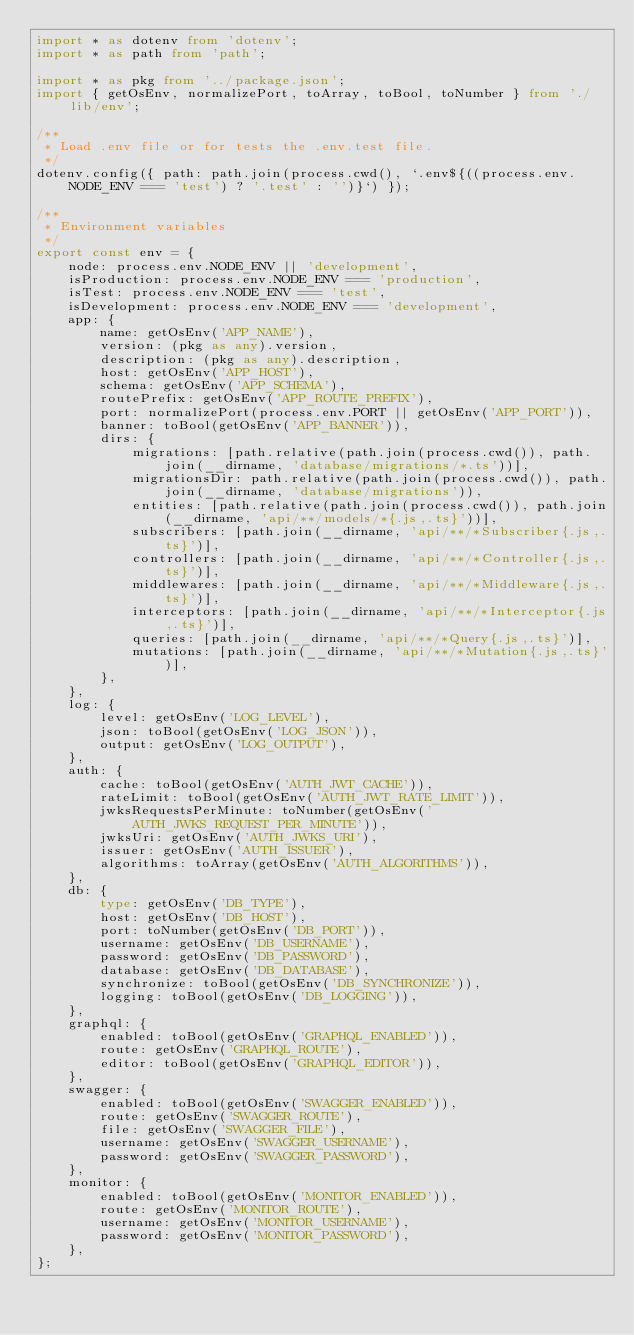Convert code to text. <code><loc_0><loc_0><loc_500><loc_500><_TypeScript_>import * as dotenv from 'dotenv';
import * as path from 'path';

import * as pkg from '../package.json';
import { getOsEnv, normalizePort, toArray, toBool, toNumber } from './lib/env';

/**
 * Load .env file or for tests the .env.test file.
 */
dotenv.config({ path: path.join(process.cwd(), `.env${((process.env.NODE_ENV === 'test') ? '.test' : '')}`) });

/**
 * Environment variables
 */
export const env = {
    node: process.env.NODE_ENV || 'development',
    isProduction: process.env.NODE_ENV === 'production',
    isTest: process.env.NODE_ENV === 'test',
    isDevelopment: process.env.NODE_ENV === 'development',
    app: {
        name: getOsEnv('APP_NAME'),
        version: (pkg as any).version,
        description: (pkg as any).description,
        host: getOsEnv('APP_HOST'),
        schema: getOsEnv('APP_SCHEMA'),
        routePrefix: getOsEnv('APP_ROUTE_PREFIX'),
        port: normalizePort(process.env.PORT || getOsEnv('APP_PORT')),
        banner: toBool(getOsEnv('APP_BANNER')),
        dirs: {
            migrations: [path.relative(path.join(process.cwd()), path.join(__dirname, 'database/migrations/*.ts'))],
            migrationsDir: path.relative(path.join(process.cwd()), path.join(__dirname, 'database/migrations')),
            entities: [path.relative(path.join(process.cwd()), path.join(__dirname, 'api/**/models/*{.js,.ts}'))],
            subscribers: [path.join(__dirname, 'api/**/*Subscriber{.js,.ts}')],
            controllers: [path.join(__dirname, 'api/**/*Controller{.js,.ts}')],
            middlewares: [path.join(__dirname, 'api/**/*Middleware{.js,.ts}')],
            interceptors: [path.join(__dirname, 'api/**/*Interceptor{.js,.ts}')],
            queries: [path.join(__dirname, 'api/**/*Query{.js,.ts}')],
            mutations: [path.join(__dirname, 'api/**/*Mutation{.js,.ts}')],
        },
    },
    log: {
        level: getOsEnv('LOG_LEVEL'),
        json: toBool(getOsEnv('LOG_JSON')),
        output: getOsEnv('LOG_OUTPUT'),
    },
    auth: {
        cache: toBool(getOsEnv('AUTH_JWT_CACHE')),
        rateLimit: toBool(getOsEnv('AUTH_JWT_RATE_LIMIT')),
        jwksRequestsPerMinute: toNumber(getOsEnv('AUTH_JWKS_REQUEST_PER_MINUTE')),
        jwksUri: getOsEnv('AUTH_JWKS_URI'),
        issuer: getOsEnv('AUTH_ISSUER'),
        algorithms: toArray(getOsEnv('AUTH_ALGORITHMS')),
    },
    db: {
        type: getOsEnv('DB_TYPE'),
        host: getOsEnv('DB_HOST'),
        port: toNumber(getOsEnv('DB_PORT')),
        username: getOsEnv('DB_USERNAME'),
        password: getOsEnv('DB_PASSWORD'),
        database: getOsEnv('DB_DATABASE'),
        synchronize: toBool(getOsEnv('DB_SYNCHRONIZE')),
        logging: toBool(getOsEnv('DB_LOGGING')),
    },
    graphql: {
        enabled: toBool(getOsEnv('GRAPHQL_ENABLED')),
        route: getOsEnv('GRAPHQL_ROUTE'),
        editor: toBool(getOsEnv('GRAPHQL_EDITOR')),
    },
    swagger: {
        enabled: toBool(getOsEnv('SWAGGER_ENABLED')),
        route: getOsEnv('SWAGGER_ROUTE'),
        file: getOsEnv('SWAGGER_FILE'),
        username: getOsEnv('SWAGGER_USERNAME'),
        password: getOsEnv('SWAGGER_PASSWORD'),
    },
    monitor: {
        enabled: toBool(getOsEnv('MONITOR_ENABLED')),
        route: getOsEnv('MONITOR_ROUTE'),
        username: getOsEnv('MONITOR_USERNAME'),
        password: getOsEnv('MONITOR_PASSWORD'),
    },
};
</code> 